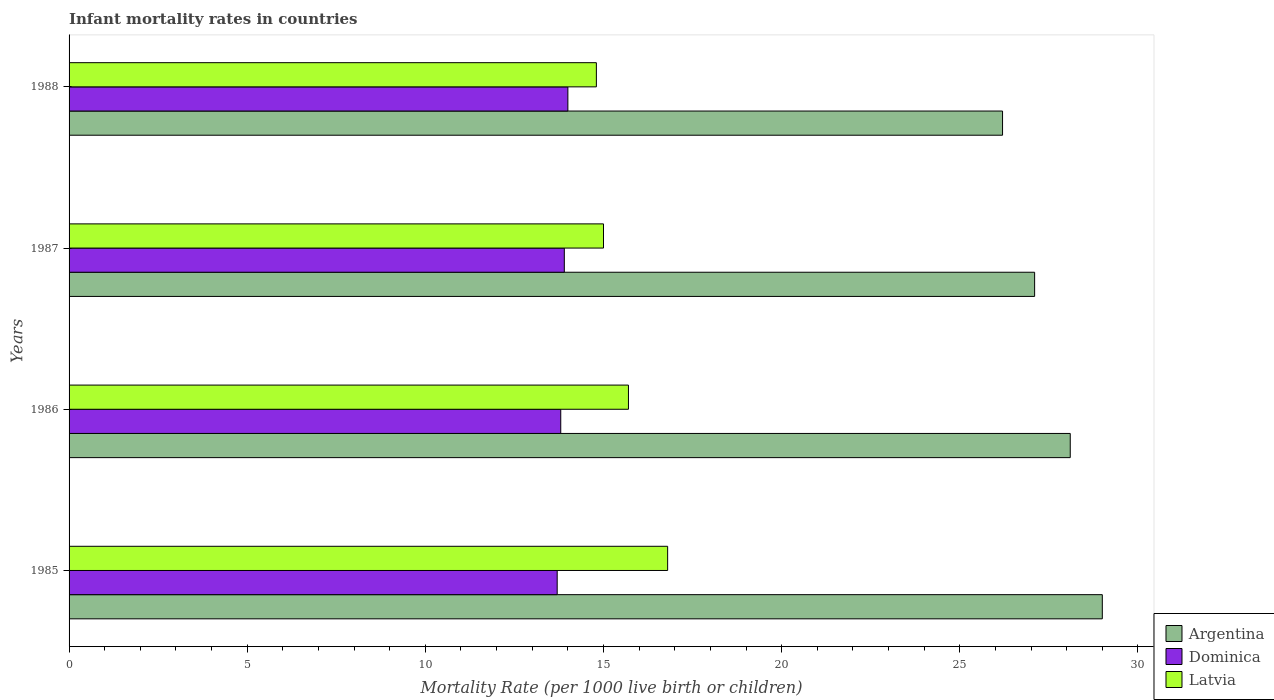How many groups of bars are there?
Your answer should be compact. 4. Are the number of bars per tick equal to the number of legend labels?
Offer a terse response. Yes. How many bars are there on the 4th tick from the top?
Offer a terse response. 3. What is the label of the 3rd group of bars from the top?
Your answer should be compact. 1986. Across all years, what is the maximum infant mortality rate in Argentina?
Your answer should be very brief. 29. In which year was the infant mortality rate in Latvia maximum?
Offer a very short reply. 1985. What is the total infant mortality rate in Argentina in the graph?
Provide a short and direct response. 110.4. What is the difference between the infant mortality rate in Latvia in 1986 and that in 1987?
Provide a succinct answer. 0.7. What is the difference between the infant mortality rate in Dominica in 1987 and the infant mortality rate in Latvia in 1988?
Your answer should be very brief. -0.9. What is the average infant mortality rate in Latvia per year?
Your answer should be very brief. 15.57. In the year 1986, what is the difference between the infant mortality rate in Argentina and infant mortality rate in Dominica?
Your answer should be very brief. 14.3. What is the ratio of the infant mortality rate in Argentina in 1986 to that in 1988?
Make the answer very short. 1.07. Is the infant mortality rate in Argentina in 1985 less than that in 1988?
Your response must be concise. No. Is the difference between the infant mortality rate in Argentina in 1985 and 1986 greater than the difference between the infant mortality rate in Dominica in 1985 and 1986?
Provide a succinct answer. Yes. What is the difference between the highest and the second highest infant mortality rate in Latvia?
Offer a very short reply. 1.1. What is the difference between the highest and the lowest infant mortality rate in Dominica?
Give a very brief answer. 0.3. In how many years, is the infant mortality rate in Argentina greater than the average infant mortality rate in Argentina taken over all years?
Offer a terse response. 2. Is the sum of the infant mortality rate in Dominica in 1985 and 1986 greater than the maximum infant mortality rate in Latvia across all years?
Keep it short and to the point. Yes. What does the 1st bar from the top in 1988 represents?
Ensure brevity in your answer.  Latvia. How many bars are there?
Your answer should be very brief. 12. What is the difference between two consecutive major ticks on the X-axis?
Provide a succinct answer. 5. Are the values on the major ticks of X-axis written in scientific E-notation?
Offer a terse response. No. Does the graph contain any zero values?
Ensure brevity in your answer.  No. Does the graph contain grids?
Make the answer very short. No. How many legend labels are there?
Offer a very short reply. 3. How are the legend labels stacked?
Keep it short and to the point. Vertical. What is the title of the graph?
Make the answer very short. Infant mortality rates in countries. What is the label or title of the X-axis?
Your response must be concise. Mortality Rate (per 1000 live birth or children). What is the Mortality Rate (per 1000 live birth or children) of Dominica in 1985?
Keep it short and to the point. 13.7. What is the Mortality Rate (per 1000 live birth or children) of Latvia in 1985?
Your response must be concise. 16.8. What is the Mortality Rate (per 1000 live birth or children) of Argentina in 1986?
Give a very brief answer. 28.1. What is the Mortality Rate (per 1000 live birth or children) of Argentina in 1987?
Provide a succinct answer. 27.1. What is the Mortality Rate (per 1000 live birth or children) in Latvia in 1987?
Your answer should be compact. 15. What is the Mortality Rate (per 1000 live birth or children) of Argentina in 1988?
Make the answer very short. 26.2. What is the Mortality Rate (per 1000 live birth or children) of Latvia in 1988?
Offer a terse response. 14.8. Across all years, what is the maximum Mortality Rate (per 1000 live birth or children) of Dominica?
Ensure brevity in your answer.  14. Across all years, what is the minimum Mortality Rate (per 1000 live birth or children) of Argentina?
Your answer should be compact. 26.2. Across all years, what is the minimum Mortality Rate (per 1000 live birth or children) in Latvia?
Give a very brief answer. 14.8. What is the total Mortality Rate (per 1000 live birth or children) of Argentina in the graph?
Provide a succinct answer. 110.4. What is the total Mortality Rate (per 1000 live birth or children) of Dominica in the graph?
Make the answer very short. 55.4. What is the total Mortality Rate (per 1000 live birth or children) of Latvia in the graph?
Provide a succinct answer. 62.3. What is the difference between the Mortality Rate (per 1000 live birth or children) in Latvia in 1985 and that in 1986?
Your answer should be very brief. 1.1. What is the difference between the Mortality Rate (per 1000 live birth or children) of Argentina in 1985 and that in 1987?
Your answer should be very brief. 1.9. What is the difference between the Mortality Rate (per 1000 live birth or children) in Latvia in 1985 and that in 1987?
Give a very brief answer. 1.8. What is the difference between the Mortality Rate (per 1000 live birth or children) in Argentina in 1985 and that in 1988?
Provide a succinct answer. 2.8. What is the difference between the Mortality Rate (per 1000 live birth or children) in Dominica in 1985 and that in 1988?
Provide a succinct answer. -0.3. What is the difference between the Mortality Rate (per 1000 live birth or children) of Latvia in 1986 and that in 1987?
Give a very brief answer. 0.7. What is the difference between the Mortality Rate (per 1000 live birth or children) of Argentina in 1986 and that in 1988?
Ensure brevity in your answer.  1.9. What is the difference between the Mortality Rate (per 1000 live birth or children) in Latvia in 1986 and that in 1988?
Offer a terse response. 0.9. What is the difference between the Mortality Rate (per 1000 live birth or children) in Argentina in 1987 and that in 1988?
Your answer should be very brief. 0.9. What is the difference between the Mortality Rate (per 1000 live birth or children) in Dominica in 1987 and that in 1988?
Keep it short and to the point. -0.1. What is the difference between the Mortality Rate (per 1000 live birth or children) of Latvia in 1987 and that in 1988?
Make the answer very short. 0.2. What is the difference between the Mortality Rate (per 1000 live birth or children) of Argentina in 1985 and the Mortality Rate (per 1000 live birth or children) of Dominica in 1986?
Ensure brevity in your answer.  15.2. What is the difference between the Mortality Rate (per 1000 live birth or children) of Dominica in 1985 and the Mortality Rate (per 1000 live birth or children) of Latvia in 1986?
Your response must be concise. -2. What is the difference between the Mortality Rate (per 1000 live birth or children) in Argentina in 1985 and the Mortality Rate (per 1000 live birth or children) in Latvia in 1988?
Your response must be concise. 14.2. What is the difference between the Mortality Rate (per 1000 live birth or children) in Dominica in 1985 and the Mortality Rate (per 1000 live birth or children) in Latvia in 1988?
Your response must be concise. -1.1. What is the difference between the Mortality Rate (per 1000 live birth or children) of Argentina in 1986 and the Mortality Rate (per 1000 live birth or children) of Dominica in 1987?
Provide a succinct answer. 14.2. What is the difference between the Mortality Rate (per 1000 live birth or children) in Argentina in 1986 and the Mortality Rate (per 1000 live birth or children) in Latvia in 1987?
Your response must be concise. 13.1. What is the difference between the Mortality Rate (per 1000 live birth or children) of Dominica in 1986 and the Mortality Rate (per 1000 live birth or children) of Latvia in 1987?
Make the answer very short. -1.2. What is the difference between the Mortality Rate (per 1000 live birth or children) of Argentina in 1986 and the Mortality Rate (per 1000 live birth or children) of Latvia in 1988?
Keep it short and to the point. 13.3. What is the difference between the Mortality Rate (per 1000 live birth or children) in Dominica in 1986 and the Mortality Rate (per 1000 live birth or children) in Latvia in 1988?
Ensure brevity in your answer.  -1. What is the difference between the Mortality Rate (per 1000 live birth or children) of Argentina in 1987 and the Mortality Rate (per 1000 live birth or children) of Latvia in 1988?
Offer a very short reply. 12.3. What is the average Mortality Rate (per 1000 live birth or children) in Argentina per year?
Offer a terse response. 27.6. What is the average Mortality Rate (per 1000 live birth or children) in Dominica per year?
Give a very brief answer. 13.85. What is the average Mortality Rate (per 1000 live birth or children) of Latvia per year?
Offer a very short reply. 15.57. In the year 1985, what is the difference between the Mortality Rate (per 1000 live birth or children) of Argentina and Mortality Rate (per 1000 live birth or children) of Latvia?
Provide a succinct answer. 12.2. In the year 1986, what is the difference between the Mortality Rate (per 1000 live birth or children) in Argentina and Mortality Rate (per 1000 live birth or children) in Latvia?
Your answer should be compact. 12.4. In the year 1987, what is the difference between the Mortality Rate (per 1000 live birth or children) of Argentina and Mortality Rate (per 1000 live birth or children) of Dominica?
Provide a succinct answer. 13.2. In the year 1987, what is the difference between the Mortality Rate (per 1000 live birth or children) in Dominica and Mortality Rate (per 1000 live birth or children) in Latvia?
Offer a terse response. -1.1. In the year 1988, what is the difference between the Mortality Rate (per 1000 live birth or children) of Argentina and Mortality Rate (per 1000 live birth or children) of Dominica?
Provide a short and direct response. 12.2. In the year 1988, what is the difference between the Mortality Rate (per 1000 live birth or children) of Argentina and Mortality Rate (per 1000 live birth or children) of Latvia?
Give a very brief answer. 11.4. What is the ratio of the Mortality Rate (per 1000 live birth or children) of Argentina in 1985 to that in 1986?
Offer a very short reply. 1.03. What is the ratio of the Mortality Rate (per 1000 live birth or children) of Latvia in 1985 to that in 1986?
Give a very brief answer. 1.07. What is the ratio of the Mortality Rate (per 1000 live birth or children) in Argentina in 1985 to that in 1987?
Your answer should be compact. 1.07. What is the ratio of the Mortality Rate (per 1000 live birth or children) of Dominica in 1985 to that in 1987?
Provide a succinct answer. 0.99. What is the ratio of the Mortality Rate (per 1000 live birth or children) in Latvia in 1985 to that in 1987?
Provide a succinct answer. 1.12. What is the ratio of the Mortality Rate (per 1000 live birth or children) in Argentina in 1985 to that in 1988?
Keep it short and to the point. 1.11. What is the ratio of the Mortality Rate (per 1000 live birth or children) in Dominica in 1985 to that in 1988?
Offer a very short reply. 0.98. What is the ratio of the Mortality Rate (per 1000 live birth or children) of Latvia in 1985 to that in 1988?
Provide a succinct answer. 1.14. What is the ratio of the Mortality Rate (per 1000 live birth or children) in Argentina in 1986 to that in 1987?
Your response must be concise. 1.04. What is the ratio of the Mortality Rate (per 1000 live birth or children) of Dominica in 1986 to that in 1987?
Provide a short and direct response. 0.99. What is the ratio of the Mortality Rate (per 1000 live birth or children) of Latvia in 1986 to that in 1987?
Ensure brevity in your answer.  1.05. What is the ratio of the Mortality Rate (per 1000 live birth or children) of Argentina in 1986 to that in 1988?
Keep it short and to the point. 1.07. What is the ratio of the Mortality Rate (per 1000 live birth or children) of Dominica in 1986 to that in 1988?
Your answer should be very brief. 0.99. What is the ratio of the Mortality Rate (per 1000 live birth or children) of Latvia in 1986 to that in 1988?
Your answer should be very brief. 1.06. What is the ratio of the Mortality Rate (per 1000 live birth or children) of Argentina in 1987 to that in 1988?
Make the answer very short. 1.03. What is the ratio of the Mortality Rate (per 1000 live birth or children) of Dominica in 1987 to that in 1988?
Provide a short and direct response. 0.99. What is the ratio of the Mortality Rate (per 1000 live birth or children) of Latvia in 1987 to that in 1988?
Make the answer very short. 1.01. What is the difference between the highest and the second highest Mortality Rate (per 1000 live birth or children) in Latvia?
Offer a very short reply. 1.1. What is the difference between the highest and the lowest Mortality Rate (per 1000 live birth or children) in Dominica?
Ensure brevity in your answer.  0.3. 